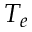Convert formula to latex. <formula><loc_0><loc_0><loc_500><loc_500>T _ { e }</formula> 